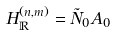Convert formula to latex. <formula><loc_0><loc_0><loc_500><loc_500>H _ { \mathbb { R } } ^ { ( n , m ) } = { \tilde { N } } _ { 0 } A _ { 0 }</formula> 